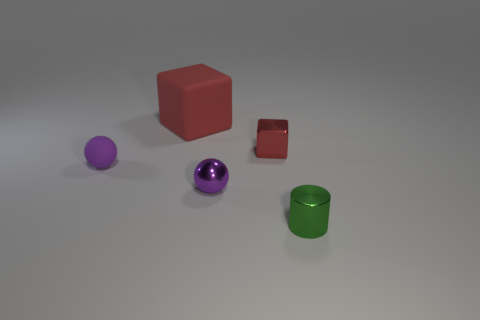Is there anything else that has the same color as the tiny metallic block?
Your response must be concise. Yes. The tiny shiny object that is to the right of the tiny metallic sphere and behind the small green cylinder has what shape?
Offer a very short reply. Cube. Are there the same number of metal blocks left of the big red object and green cylinders that are behind the tiny purple rubber object?
Provide a short and direct response. Yes. How many cubes are either large things or tiny metal objects?
Your answer should be compact. 2. How many green cylinders are made of the same material as the large cube?
Offer a terse response. 0. There is a tiny metallic object that is the same color as the matte ball; what is its shape?
Offer a very short reply. Sphere. The object that is on the left side of the purple shiny ball and to the right of the small matte object is made of what material?
Your answer should be very brief. Rubber. There is a tiny purple thing left of the big object; what shape is it?
Make the answer very short. Sphere. There is a rubber object left of the large cube behind the small red object; what is its shape?
Make the answer very short. Sphere. Are there any other things that have the same shape as the purple metal object?
Your answer should be compact. Yes. 